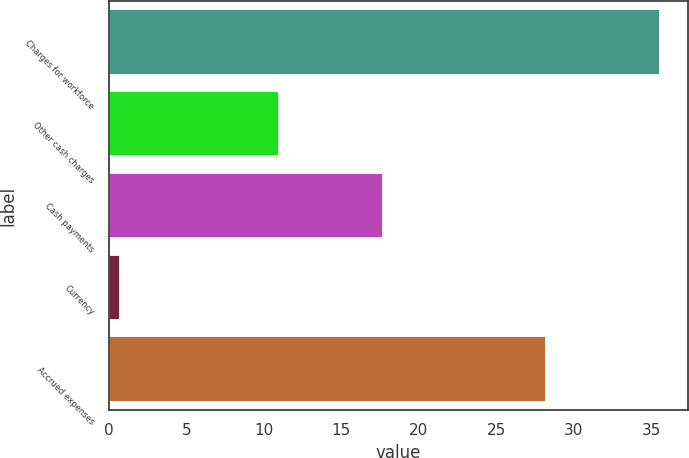Convert chart. <chart><loc_0><loc_0><loc_500><loc_500><bar_chart><fcel>Charges for workforce<fcel>Other cash charges<fcel>Cash payments<fcel>Currency<fcel>Accrued expenses<nl><fcel>35.6<fcel>11<fcel>17.7<fcel>0.7<fcel>28.2<nl></chart> 